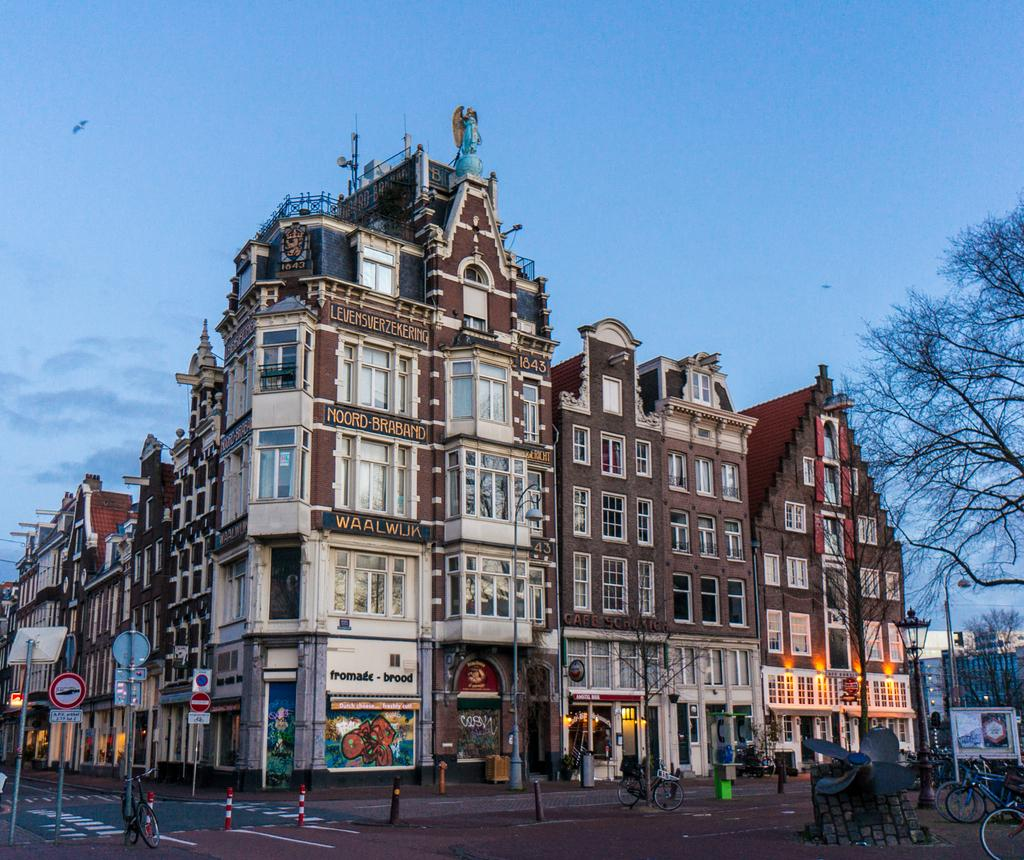What type of vehicles can be seen in the image? There are bicycles in the image. What structures are present in the image? There are poles, lights, boards, a dustbin, a road, trees, buildings, and the sky is visible in the background. Can you describe the weather in the image? The sky is visible in the background, and there are clouds in the sky, suggesting a partly cloudy day. What type of alarm can be heard in the image? There is no alarm present in the image, as it is a still image and cannot produce sound. 